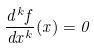Convert formula to latex. <formula><loc_0><loc_0><loc_500><loc_500>\frac { d ^ { k } f } { d x ^ { k } } ( x ) = 0</formula> 